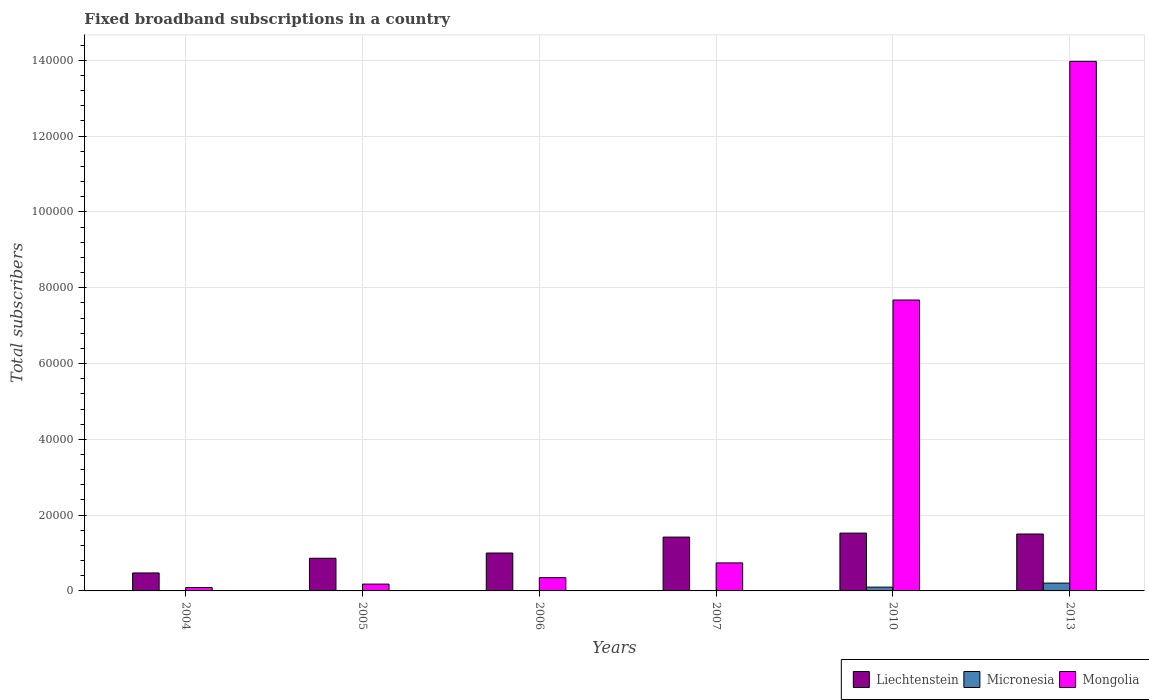How many groups of bars are there?
Keep it short and to the point. 6. Are the number of bars per tick equal to the number of legend labels?
Make the answer very short. Yes. How many bars are there on the 5th tick from the left?
Provide a short and direct response. 3. What is the label of the 5th group of bars from the left?
Your response must be concise. 2010. In how many cases, is the number of bars for a given year not equal to the number of legend labels?
Ensure brevity in your answer.  0. What is the number of broadband subscriptions in Mongolia in 2010?
Your answer should be very brief. 7.68e+04. Across all years, what is the maximum number of broadband subscriptions in Micronesia?
Keep it short and to the point. 2063. Across all years, what is the minimum number of broadband subscriptions in Mongolia?
Offer a terse response. 900. What is the total number of broadband subscriptions in Liechtenstein in the graph?
Your answer should be very brief. 6.78e+04. What is the difference between the number of broadband subscriptions in Micronesia in 2004 and that in 2013?
Provide a succinct answer. -2037. What is the difference between the number of broadband subscriptions in Micronesia in 2006 and the number of broadband subscriptions in Mongolia in 2013?
Ensure brevity in your answer.  -1.40e+05. What is the average number of broadband subscriptions in Liechtenstein per year?
Ensure brevity in your answer.  1.13e+04. In the year 2007, what is the difference between the number of broadband subscriptions in Micronesia and number of broadband subscriptions in Mongolia?
Your answer should be compact. -7279. In how many years, is the number of broadband subscriptions in Mongolia greater than 72000?
Keep it short and to the point. 2. What is the ratio of the number of broadband subscriptions in Mongolia in 2004 to that in 2013?
Your response must be concise. 0.01. What is the difference between the highest and the second highest number of broadband subscriptions in Micronesia?
Ensure brevity in your answer.  1065. What is the difference between the highest and the lowest number of broadband subscriptions in Liechtenstein?
Make the answer very short. 1.05e+04. What does the 2nd bar from the left in 2010 represents?
Your answer should be very brief. Micronesia. What does the 1st bar from the right in 2013 represents?
Your answer should be compact. Mongolia. Is it the case that in every year, the sum of the number of broadband subscriptions in Mongolia and number of broadband subscriptions in Micronesia is greater than the number of broadband subscriptions in Liechtenstein?
Provide a succinct answer. No. Are all the bars in the graph horizontal?
Keep it short and to the point. No. How many years are there in the graph?
Your answer should be compact. 6. What is the difference between two consecutive major ticks on the Y-axis?
Provide a succinct answer. 2.00e+04. Are the values on the major ticks of Y-axis written in scientific E-notation?
Give a very brief answer. No. Does the graph contain any zero values?
Your answer should be compact. No. Does the graph contain grids?
Your answer should be compact. Yes. Where does the legend appear in the graph?
Your answer should be very brief. Bottom right. How are the legend labels stacked?
Provide a succinct answer. Horizontal. What is the title of the graph?
Offer a terse response. Fixed broadband subscriptions in a country. Does "Andorra" appear as one of the legend labels in the graph?
Provide a short and direct response. No. What is the label or title of the Y-axis?
Make the answer very short. Total subscribers. What is the Total subscribers of Liechtenstein in 2004?
Ensure brevity in your answer.  4741. What is the Total subscribers in Micronesia in 2004?
Your response must be concise. 26. What is the Total subscribers in Mongolia in 2004?
Ensure brevity in your answer.  900. What is the Total subscribers of Liechtenstein in 2005?
Your answer should be compact. 8617. What is the Total subscribers of Mongolia in 2005?
Your answer should be very brief. 1800. What is the Total subscribers of Micronesia in 2006?
Keep it short and to the point. 95. What is the Total subscribers in Mongolia in 2006?
Your answer should be compact. 3500. What is the Total subscribers of Liechtenstein in 2007?
Ensure brevity in your answer.  1.42e+04. What is the Total subscribers of Micronesia in 2007?
Provide a short and direct response. 116. What is the Total subscribers in Mongolia in 2007?
Make the answer very short. 7395. What is the Total subscribers in Liechtenstein in 2010?
Give a very brief answer. 1.52e+04. What is the Total subscribers in Micronesia in 2010?
Give a very brief answer. 998. What is the Total subscribers in Mongolia in 2010?
Your response must be concise. 7.68e+04. What is the Total subscribers in Liechtenstein in 2013?
Ensure brevity in your answer.  1.50e+04. What is the Total subscribers in Micronesia in 2013?
Offer a very short reply. 2063. What is the Total subscribers of Mongolia in 2013?
Your response must be concise. 1.40e+05. Across all years, what is the maximum Total subscribers of Liechtenstein?
Keep it short and to the point. 1.52e+04. Across all years, what is the maximum Total subscribers of Micronesia?
Offer a very short reply. 2063. Across all years, what is the maximum Total subscribers in Mongolia?
Ensure brevity in your answer.  1.40e+05. Across all years, what is the minimum Total subscribers of Liechtenstein?
Give a very brief answer. 4741. Across all years, what is the minimum Total subscribers of Mongolia?
Make the answer very short. 900. What is the total Total subscribers of Liechtenstein in the graph?
Offer a very short reply. 6.78e+04. What is the total Total subscribers of Micronesia in the graph?
Your answer should be compact. 3344. What is the total Total subscribers in Mongolia in the graph?
Keep it short and to the point. 2.30e+05. What is the difference between the Total subscribers in Liechtenstein in 2004 and that in 2005?
Your response must be concise. -3876. What is the difference between the Total subscribers of Micronesia in 2004 and that in 2005?
Keep it short and to the point. -20. What is the difference between the Total subscribers of Mongolia in 2004 and that in 2005?
Your answer should be very brief. -900. What is the difference between the Total subscribers in Liechtenstein in 2004 and that in 2006?
Offer a very short reply. -5259. What is the difference between the Total subscribers of Micronesia in 2004 and that in 2006?
Provide a succinct answer. -69. What is the difference between the Total subscribers of Mongolia in 2004 and that in 2006?
Keep it short and to the point. -2600. What is the difference between the Total subscribers in Liechtenstein in 2004 and that in 2007?
Your response must be concise. -9459. What is the difference between the Total subscribers of Micronesia in 2004 and that in 2007?
Give a very brief answer. -90. What is the difference between the Total subscribers of Mongolia in 2004 and that in 2007?
Your answer should be very brief. -6495. What is the difference between the Total subscribers in Liechtenstein in 2004 and that in 2010?
Give a very brief answer. -1.05e+04. What is the difference between the Total subscribers in Micronesia in 2004 and that in 2010?
Provide a short and direct response. -972. What is the difference between the Total subscribers in Mongolia in 2004 and that in 2010?
Make the answer very short. -7.59e+04. What is the difference between the Total subscribers of Liechtenstein in 2004 and that in 2013?
Provide a short and direct response. -1.03e+04. What is the difference between the Total subscribers in Micronesia in 2004 and that in 2013?
Provide a short and direct response. -2037. What is the difference between the Total subscribers of Mongolia in 2004 and that in 2013?
Give a very brief answer. -1.39e+05. What is the difference between the Total subscribers in Liechtenstein in 2005 and that in 2006?
Your response must be concise. -1383. What is the difference between the Total subscribers of Micronesia in 2005 and that in 2006?
Your answer should be compact. -49. What is the difference between the Total subscribers in Mongolia in 2005 and that in 2006?
Ensure brevity in your answer.  -1700. What is the difference between the Total subscribers of Liechtenstein in 2005 and that in 2007?
Your response must be concise. -5583. What is the difference between the Total subscribers in Micronesia in 2005 and that in 2007?
Keep it short and to the point. -70. What is the difference between the Total subscribers in Mongolia in 2005 and that in 2007?
Offer a very short reply. -5595. What is the difference between the Total subscribers of Liechtenstein in 2005 and that in 2010?
Your response must be concise. -6633. What is the difference between the Total subscribers in Micronesia in 2005 and that in 2010?
Provide a short and direct response. -952. What is the difference between the Total subscribers of Mongolia in 2005 and that in 2010?
Your answer should be very brief. -7.50e+04. What is the difference between the Total subscribers of Liechtenstein in 2005 and that in 2013?
Give a very brief answer. -6399. What is the difference between the Total subscribers of Micronesia in 2005 and that in 2013?
Keep it short and to the point. -2017. What is the difference between the Total subscribers of Mongolia in 2005 and that in 2013?
Ensure brevity in your answer.  -1.38e+05. What is the difference between the Total subscribers in Liechtenstein in 2006 and that in 2007?
Keep it short and to the point. -4200. What is the difference between the Total subscribers in Mongolia in 2006 and that in 2007?
Your answer should be compact. -3895. What is the difference between the Total subscribers in Liechtenstein in 2006 and that in 2010?
Keep it short and to the point. -5250. What is the difference between the Total subscribers in Micronesia in 2006 and that in 2010?
Ensure brevity in your answer.  -903. What is the difference between the Total subscribers in Mongolia in 2006 and that in 2010?
Provide a short and direct response. -7.33e+04. What is the difference between the Total subscribers of Liechtenstein in 2006 and that in 2013?
Your answer should be compact. -5016. What is the difference between the Total subscribers of Micronesia in 2006 and that in 2013?
Your answer should be very brief. -1968. What is the difference between the Total subscribers in Mongolia in 2006 and that in 2013?
Give a very brief answer. -1.36e+05. What is the difference between the Total subscribers of Liechtenstein in 2007 and that in 2010?
Give a very brief answer. -1050. What is the difference between the Total subscribers of Micronesia in 2007 and that in 2010?
Your answer should be compact. -882. What is the difference between the Total subscribers in Mongolia in 2007 and that in 2010?
Your answer should be compact. -6.94e+04. What is the difference between the Total subscribers in Liechtenstein in 2007 and that in 2013?
Keep it short and to the point. -816. What is the difference between the Total subscribers in Micronesia in 2007 and that in 2013?
Provide a short and direct response. -1947. What is the difference between the Total subscribers in Mongolia in 2007 and that in 2013?
Your answer should be compact. -1.32e+05. What is the difference between the Total subscribers of Liechtenstein in 2010 and that in 2013?
Your answer should be very brief. 234. What is the difference between the Total subscribers of Micronesia in 2010 and that in 2013?
Your answer should be very brief. -1065. What is the difference between the Total subscribers in Mongolia in 2010 and that in 2013?
Give a very brief answer. -6.30e+04. What is the difference between the Total subscribers in Liechtenstein in 2004 and the Total subscribers in Micronesia in 2005?
Offer a very short reply. 4695. What is the difference between the Total subscribers of Liechtenstein in 2004 and the Total subscribers of Mongolia in 2005?
Keep it short and to the point. 2941. What is the difference between the Total subscribers of Micronesia in 2004 and the Total subscribers of Mongolia in 2005?
Your answer should be very brief. -1774. What is the difference between the Total subscribers in Liechtenstein in 2004 and the Total subscribers in Micronesia in 2006?
Give a very brief answer. 4646. What is the difference between the Total subscribers of Liechtenstein in 2004 and the Total subscribers of Mongolia in 2006?
Provide a short and direct response. 1241. What is the difference between the Total subscribers in Micronesia in 2004 and the Total subscribers in Mongolia in 2006?
Offer a terse response. -3474. What is the difference between the Total subscribers in Liechtenstein in 2004 and the Total subscribers in Micronesia in 2007?
Ensure brevity in your answer.  4625. What is the difference between the Total subscribers of Liechtenstein in 2004 and the Total subscribers of Mongolia in 2007?
Provide a succinct answer. -2654. What is the difference between the Total subscribers in Micronesia in 2004 and the Total subscribers in Mongolia in 2007?
Provide a short and direct response. -7369. What is the difference between the Total subscribers in Liechtenstein in 2004 and the Total subscribers in Micronesia in 2010?
Make the answer very short. 3743. What is the difference between the Total subscribers in Liechtenstein in 2004 and the Total subscribers in Mongolia in 2010?
Your answer should be compact. -7.20e+04. What is the difference between the Total subscribers of Micronesia in 2004 and the Total subscribers of Mongolia in 2010?
Your answer should be very brief. -7.67e+04. What is the difference between the Total subscribers of Liechtenstein in 2004 and the Total subscribers of Micronesia in 2013?
Give a very brief answer. 2678. What is the difference between the Total subscribers in Liechtenstein in 2004 and the Total subscribers in Mongolia in 2013?
Ensure brevity in your answer.  -1.35e+05. What is the difference between the Total subscribers of Micronesia in 2004 and the Total subscribers of Mongolia in 2013?
Offer a very short reply. -1.40e+05. What is the difference between the Total subscribers in Liechtenstein in 2005 and the Total subscribers in Micronesia in 2006?
Ensure brevity in your answer.  8522. What is the difference between the Total subscribers in Liechtenstein in 2005 and the Total subscribers in Mongolia in 2006?
Your answer should be compact. 5117. What is the difference between the Total subscribers in Micronesia in 2005 and the Total subscribers in Mongolia in 2006?
Ensure brevity in your answer.  -3454. What is the difference between the Total subscribers of Liechtenstein in 2005 and the Total subscribers of Micronesia in 2007?
Provide a short and direct response. 8501. What is the difference between the Total subscribers of Liechtenstein in 2005 and the Total subscribers of Mongolia in 2007?
Provide a succinct answer. 1222. What is the difference between the Total subscribers of Micronesia in 2005 and the Total subscribers of Mongolia in 2007?
Keep it short and to the point. -7349. What is the difference between the Total subscribers of Liechtenstein in 2005 and the Total subscribers of Micronesia in 2010?
Ensure brevity in your answer.  7619. What is the difference between the Total subscribers in Liechtenstein in 2005 and the Total subscribers in Mongolia in 2010?
Offer a terse response. -6.81e+04. What is the difference between the Total subscribers of Micronesia in 2005 and the Total subscribers of Mongolia in 2010?
Provide a succinct answer. -7.67e+04. What is the difference between the Total subscribers in Liechtenstein in 2005 and the Total subscribers in Micronesia in 2013?
Your answer should be very brief. 6554. What is the difference between the Total subscribers of Liechtenstein in 2005 and the Total subscribers of Mongolia in 2013?
Keep it short and to the point. -1.31e+05. What is the difference between the Total subscribers in Micronesia in 2005 and the Total subscribers in Mongolia in 2013?
Provide a short and direct response. -1.40e+05. What is the difference between the Total subscribers of Liechtenstein in 2006 and the Total subscribers of Micronesia in 2007?
Provide a short and direct response. 9884. What is the difference between the Total subscribers in Liechtenstein in 2006 and the Total subscribers in Mongolia in 2007?
Provide a succinct answer. 2605. What is the difference between the Total subscribers in Micronesia in 2006 and the Total subscribers in Mongolia in 2007?
Make the answer very short. -7300. What is the difference between the Total subscribers in Liechtenstein in 2006 and the Total subscribers in Micronesia in 2010?
Give a very brief answer. 9002. What is the difference between the Total subscribers of Liechtenstein in 2006 and the Total subscribers of Mongolia in 2010?
Your response must be concise. -6.68e+04. What is the difference between the Total subscribers of Micronesia in 2006 and the Total subscribers of Mongolia in 2010?
Ensure brevity in your answer.  -7.67e+04. What is the difference between the Total subscribers in Liechtenstein in 2006 and the Total subscribers in Micronesia in 2013?
Keep it short and to the point. 7937. What is the difference between the Total subscribers in Liechtenstein in 2006 and the Total subscribers in Mongolia in 2013?
Offer a very short reply. -1.30e+05. What is the difference between the Total subscribers in Micronesia in 2006 and the Total subscribers in Mongolia in 2013?
Your answer should be very brief. -1.40e+05. What is the difference between the Total subscribers in Liechtenstein in 2007 and the Total subscribers in Micronesia in 2010?
Offer a very short reply. 1.32e+04. What is the difference between the Total subscribers of Liechtenstein in 2007 and the Total subscribers of Mongolia in 2010?
Provide a succinct answer. -6.26e+04. What is the difference between the Total subscribers in Micronesia in 2007 and the Total subscribers in Mongolia in 2010?
Your response must be concise. -7.66e+04. What is the difference between the Total subscribers of Liechtenstein in 2007 and the Total subscribers of Micronesia in 2013?
Ensure brevity in your answer.  1.21e+04. What is the difference between the Total subscribers of Liechtenstein in 2007 and the Total subscribers of Mongolia in 2013?
Provide a succinct answer. -1.26e+05. What is the difference between the Total subscribers in Micronesia in 2007 and the Total subscribers in Mongolia in 2013?
Ensure brevity in your answer.  -1.40e+05. What is the difference between the Total subscribers of Liechtenstein in 2010 and the Total subscribers of Micronesia in 2013?
Keep it short and to the point. 1.32e+04. What is the difference between the Total subscribers of Liechtenstein in 2010 and the Total subscribers of Mongolia in 2013?
Ensure brevity in your answer.  -1.24e+05. What is the difference between the Total subscribers of Micronesia in 2010 and the Total subscribers of Mongolia in 2013?
Provide a short and direct response. -1.39e+05. What is the average Total subscribers in Liechtenstein per year?
Give a very brief answer. 1.13e+04. What is the average Total subscribers of Micronesia per year?
Provide a succinct answer. 557.33. What is the average Total subscribers of Mongolia per year?
Keep it short and to the point. 3.83e+04. In the year 2004, what is the difference between the Total subscribers in Liechtenstein and Total subscribers in Micronesia?
Provide a succinct answer. 4715. In the year 2004, what is the difference between the Total subscribers in Liechtenstein and Total subscribers in Mongolia?
Make the answer very short. 3841. In the year 2004, what is the difference between the Total subscribers of Micronesia and Total subscribers of Mongolia?
Make the answer very short. -874. In the year 2005, what is the difference between the Total subscribers in Liechtenstein and Total subscribers in Micronesia?
Offer a very short reply. 8571. In the year 2005, what is the difference between the Total subscribers in Liechtenstein and Total subscribers in Mongolia?
Your answer should be very brief. 6817. In the year 2005, what is the difference between the Total subscribers of Micronesia and Total subscribers of Mongolia?
Offer a terse response. -1754. In the year 2006, what is the difference between the Total subscribers of Liechtenstein and Total subscribers of Micronesia?
Give a very brief answer. 9905. In the year 2006, what is the difference between the Total subscribers of Liechtenstein and Total subscribers of Mongolia?
Provide a succinct answer. 6500. In the year 2006, what is the difference between the Total subscribers in Micronesia and Total subscribers in Mongolia?
Ensure brevity in your answer.  -3405. In the year 2007, what is the difference between the Total subscribers of Liechtenstein and Total subscribers of Micronesia?
Your answer should be compact. 1.41e+04. In the year 2007, what is the difference between the Total subscribers in Liechtenstein and Total subscribers in Mongolia?
Keep it short and to the point. 6805. In the year 2007, what is the difference between the Total subscribers of Micronesia and Total subscribers of Mongolia?
Offer a terse response. -7279. In the year 2010, what is the difference between the Total subscribers in Liechtenstein and Total subscribers in Micronesia?
Your answer should be compact. 1.43e+04. In the year 2010, what is the difference between the Total subscribers of Liechtenstein and Total subscribers of Mongolia?
Offer a terse response. -6.15e+04. In the year 2010, what is the difference between the Total subscribers of Micronesia and Total subscribers of Mongolia?
Offer a very short reply. -7.58e+04. In the year 2013, what is the difference between the Total subscribers in Liechtenstein and Total subscribers in Micronesia?
Keep it short and to the point. 1.30e+04. In the year 2013, what is the difference between the Total subscribers of Liechtenstein and Total subscribers of Mongolia?
Your answer should be very brief. -1.25e+05. In the year 2013, what is the difference between the Total subscribers of Micronesia and Total subscribers of Mongolia?
Keep it short and to the point. -1.38e+05. What is the ratio of the Total subscribers in Liechtenstein in 2004 to that in 2005?
Give a very brief answer. 0.55. What is the ratio of the Total subscribers of Micronesia in 2004 to that in 2005?
Your response must be concise. 0.57. What is the ratio of the Total subscribers in Liechtenstein in 2004 to that in 2006?
Provide a short and direct response. 0.47. What is the ratio of the Total subscribers of Micronesia in 2004 to that in 2006?
Give a very brief answer. 0.27. What is the ratio of the Total subscribers of Mongolia in 2004 to that in 2006?
Provide a short and direct response. 0.26. What is the ratio of the Total subscribers of Liechtenstein in 2004 to that in 2007?
Your response must be concise. 0.33. What is the ratio of the Total subscribers of Micronesia in 2004 to that in 2007?
Make the answer very short. 0.22. What is the ratio of the Total subscribers in Mongolia in 2004 to that in 2007?
Offer a terse response. 0.12. What is the ratio of the Total subscribers of Liechtenstein in 2004 to that in 2010?
Offer a very short reply. 0.31. What is the ratio of the Total subscribers in Micronesia in 2004 to that in 2010?
Your answer should be very brief. 0.03. What is the ratio of the Total subscribers in Mongolia in 2004 to that in 2010?
Provide a short and direct response. 0.01. What is the ratio of the Total subscribers in Liechtenstein in 2004 to that in 2013?
Your answer should be very brief. 0.32. What is the ratio of the Total subscribers of Micronesia in 2004 to that in 2013?
Offer a very short reply. 0.01. What is the ratio of the Total subscribers in Mongolia in 2004 to that in 2013?
Your response must be concise. 0.01. What is the ratio of the Total subscribers of Liechtenstein in 2005 to that in 2006?
Your answer should be compact. 0.86. What is the ratio of the Total subscribers in Micronesia in 2005 to that in 2006?
Offer a terse response. 0.48. What is the ratio of the Total subscribers of Mongolia in 2005 to that in 2006?
Your answer should be very brief. 0.51. What is the ratio of the Total subscribers of Liechtenstein in 2005 to that in 2007?
Ensure brevity in your answer.  0.61. What is the ratio of the Total subscribers of Micronesia in 2005 to that in 2007?
Your response must be concise. 0.4. What is the ratio of the Total subscribers of Mongolia in 2005 to that in 2007?
Provide a succinct answer. 0.24. What is the ratio of the Total subscribers in Liechtenstein in 2005 to that in 2010?
Provide a short and direct response. 0.56. What is the ratio of the Total subscribers of Micronesia in 2005 to that in 2010?
Make the answer very short. 0.05. What is the ratio of the Total subscribers of Mongolia in 2005 to that in 2010?
Provide a succinct answer. 0.02. What is the ratio of the Total subscribers of Liechtenstein in 2005 to that in 2013?
Your answer should be compact. 0.57. What is the ratio of the Total subscribers of Micronesia in 2005 to that in 2013?
Provide a succinct answer. 0.02. What is the ratio of the Total subscribers of Mongolia in 2005 to that in 2013?
Provide a succinct answer. 0.01. What is the ratio of the Total subscribers of Liechtenstein in 2006 to that in 2007?
Your response must be concise. 0.7. What is the ratio of the Total subscribers of Micronesia in 2006 to that in 2007?
Give a very brief answer. 0.82. What is the ratio of the Total subscribers in Mongolia in 2006 to that in 2007?
Keep it short and to the point. 0.47. What is the ratio of the Total subscribers of Liechtenstein in 2006 to that in 2010?
Give a very brief answer. 0.66. What is the ratio of the Total subscribers of Micronesia in 2006 to that in 2010?
Keep it short and to the point. 0.1. What is the ratio of the Total subscribers of Mongolia in 2006 to that in 2010?
Ensure brevity in your answer.  0.05. What is the ratio of the Total subscribers in Liechtenstein in 2006 to that in 2013?
Offer a very short reply. 0.67. What is the ratio of the Total subscribers of Micronesia in 2006 to that in 2013?
Offer a terse response. 0.05. What is the ratio of the Total subscribers of Mongolia in 2006 to that in 2013?
Make the answer very short. 0.03. What is the ratio of the Total subscribers of Liechtenstein in 2007 to that in 2010?
Provide a succinct answer. 0.93. What is the ratio of the Total subscribers of Micronesia in 2007 to that in 2010?
Your answer should be compact. 0.12. What is the ratio of the Total subscribers in Mongolia in 2007 to that in 2010?
Make the answer very short. 0.1. What is the ratio of the Total subscribers of Liechtenstein in 2007 to that in 2013?
Offer a terse response. 0.95. What is the ratio of the Total subscribers of Micronesia in 2007 to that in 2013?
Your answer should be very brief. 0.06. What is the ratio of the Total subscribers in Mongolia in 2007 to that in 2013?
Give a very brief answer. 0.05. What is the ratio of the Total subscribers of Liechtenstein in 2010 to that in 2013?
Offer a very short reply. 1.02. What is the ratio of the Total subscribers in Micronesia in 2010 to that in 2013?
Your answer should be very brief. 0.48. What is the ratio of the Total subscribers in Mongolia in 2010 to that in 2013?
Make the answer very short. 0.55. What is the difference between the highest and the second highest Total subscribers in Liechtenstein?
Keep it short and to the point. 234. What is the difference between the highest and the second highest Total subscribers of Micronesia?
Keep it short and to the point. 1065. What is the difference between the highest and the second highest Total subscribers in Mongolia?
Ensure brevity in your answer.  6.30e+04. What is the difference between the highest and the lowest Total subscribers in Liechtenstein?
Keep it short and to the point. 1.05e+04. What is the difference between the highest and the lowest Total subscribers of Micronesia?
Make the answer very short. 2037. What is the difference between the highest and the lowest Total subscribers of Mongolia?
Give a very brief answer. 1.39e+05. 